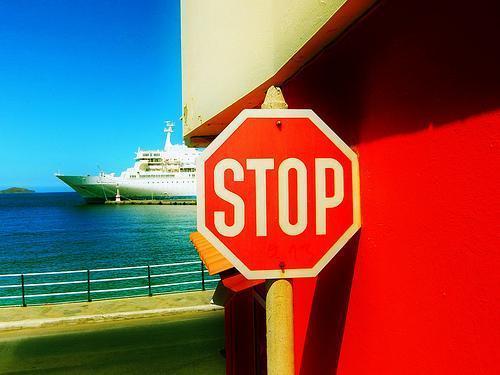How many boats are shown?
Give a very brief answer. 1. 